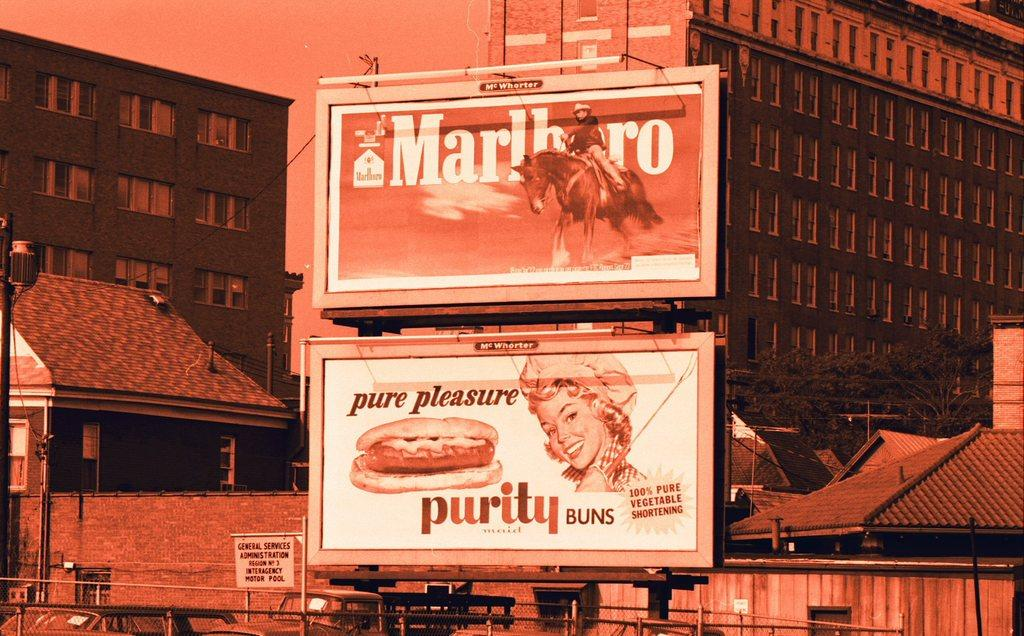<image>
Summarize the visual content of the image. the word purity is on the sign that is white 